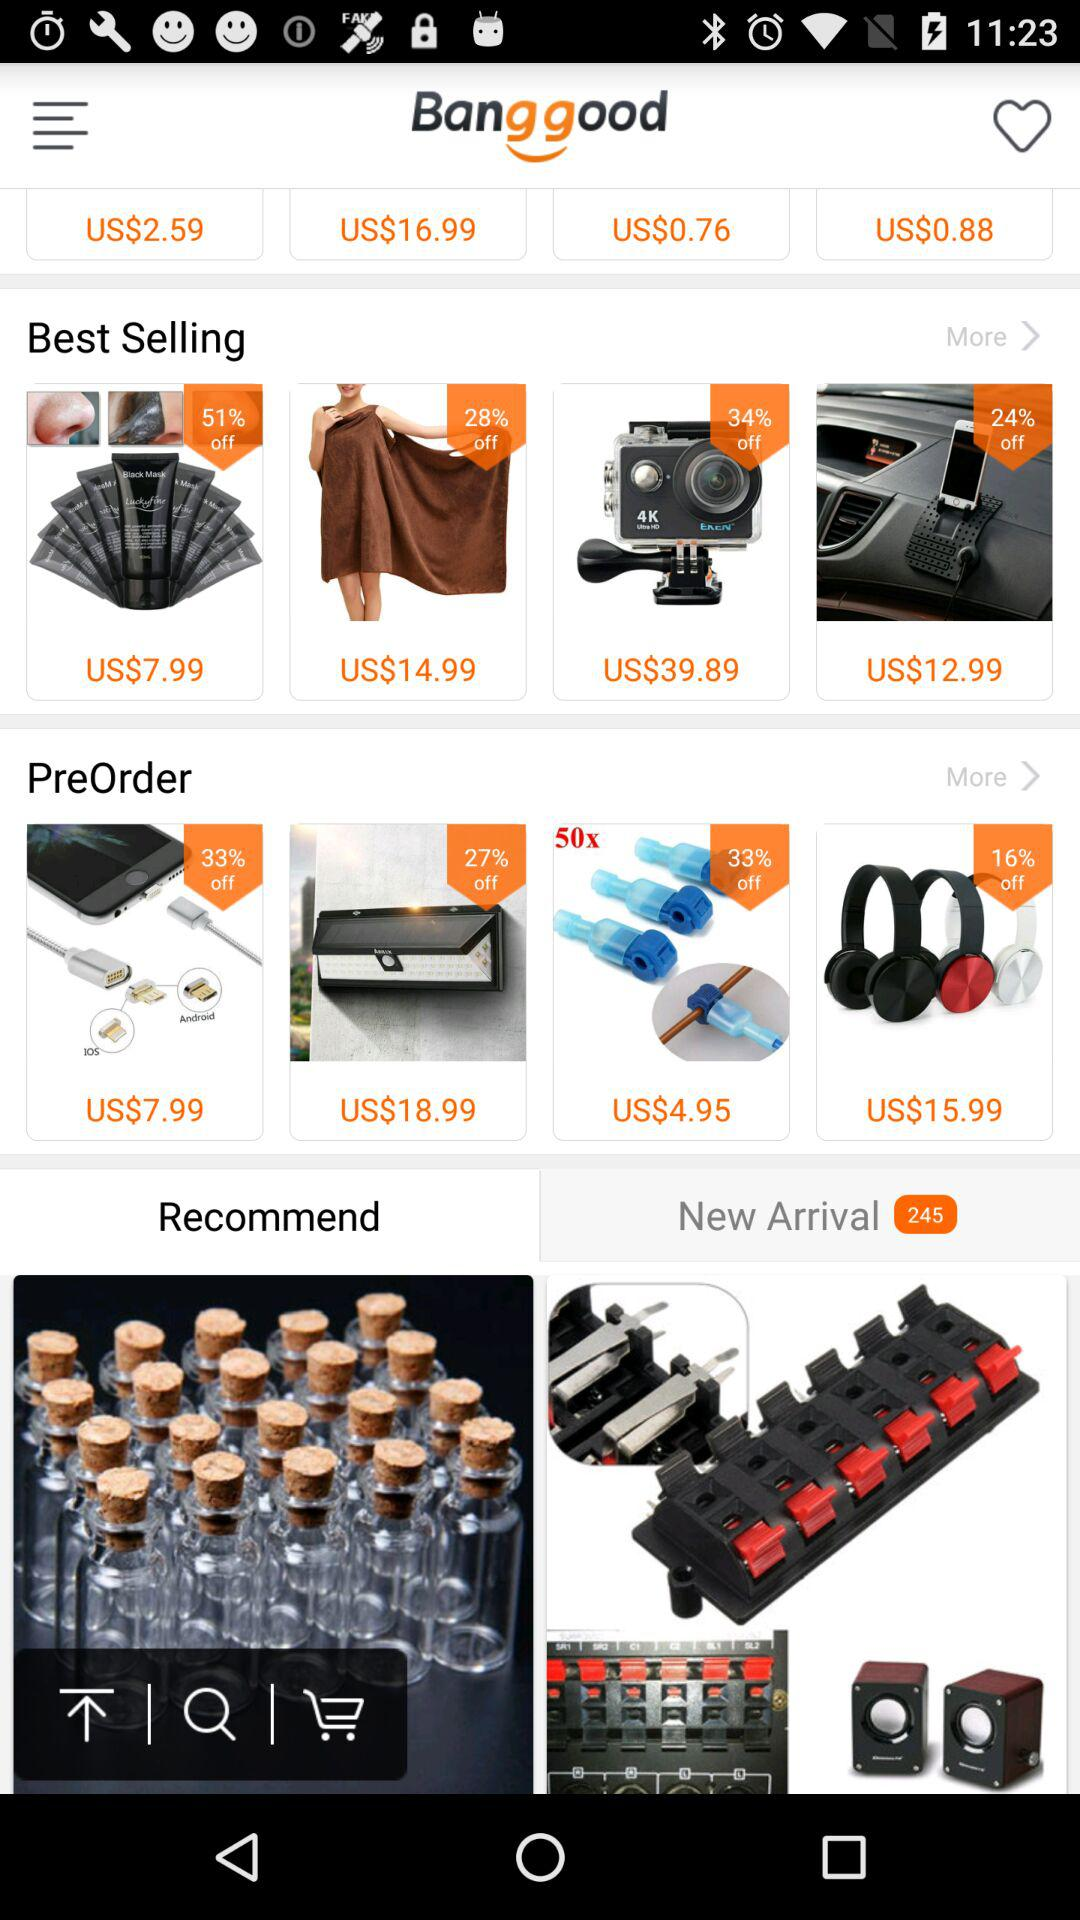How many new arrivals are there? There are 245 new arrivals. 